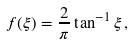Convert formula to latex. <formula><loc_0><loc_0><loc_500><loc_500>f ( \xi ) = \frac { 2 } { \pi } \tan ^ { - 1 } \xi \, ,</formula> 